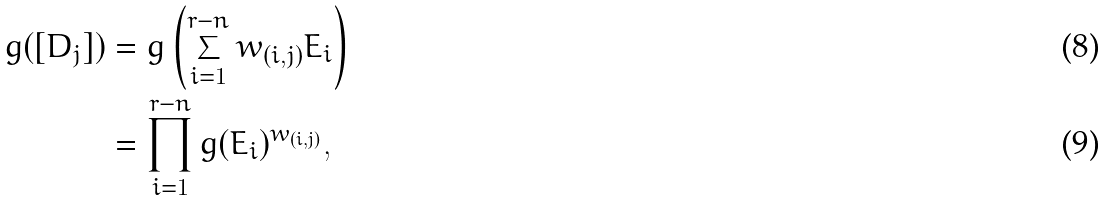<formula> <loc_0><loc_0><loc_500><loc_500>g ( [ D _ { j } ] ) & = g \left ( \sum _ { i = 1 } ^ { r - n } w _ { ( i , j ) } E _ { i } \right ) \\ & = \prod _ { i = 1 } ^ { r - n } g ( E _ { i } ) ^ { w _ { ( i , j ) } } ,</formula> 